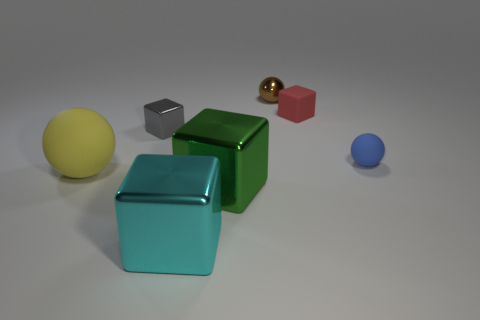What number of big things are either matte cubes or red metal objects?
Keep it short and to the point. 0. Is there a green thing made of the same material as the cyan thing?
Your response must be concise. Yes. What is the tiny blue thing that is in front of the tiny metal block made of?
Offer a very short reply. Rubber. The other metal object that is the same size as the green metal thing is what color?
Give a very brief answer. Cyan. What number of other things are the same shape as the small gray thing?
Provide a short and direct response. 3. What size is the rubber ball to the right of the large yellow rubber sphere?
Offer a very short reply. Small. How many spheres are left of the tiny sphere that is in front of the tiny metal sphere?
Offer a terse response. 2. What number of other objects are the same size as the brown shiny thing?
Offer a terse response. 3. Does the large rubber ball have the same color as the metallic sphere?
Provide a succinct answer. No. Is the shape of the large metal object that is on the left side of the green object the same as  the red rubber object?
Your response must be concise. Yes. 